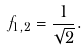Convert formula to latex. <formula><loc_0><loc_0><loc_500><loc_500>f _ { 1 , 2 } = \frac { 1 } { \sqrt { 2 } } .</formula> 